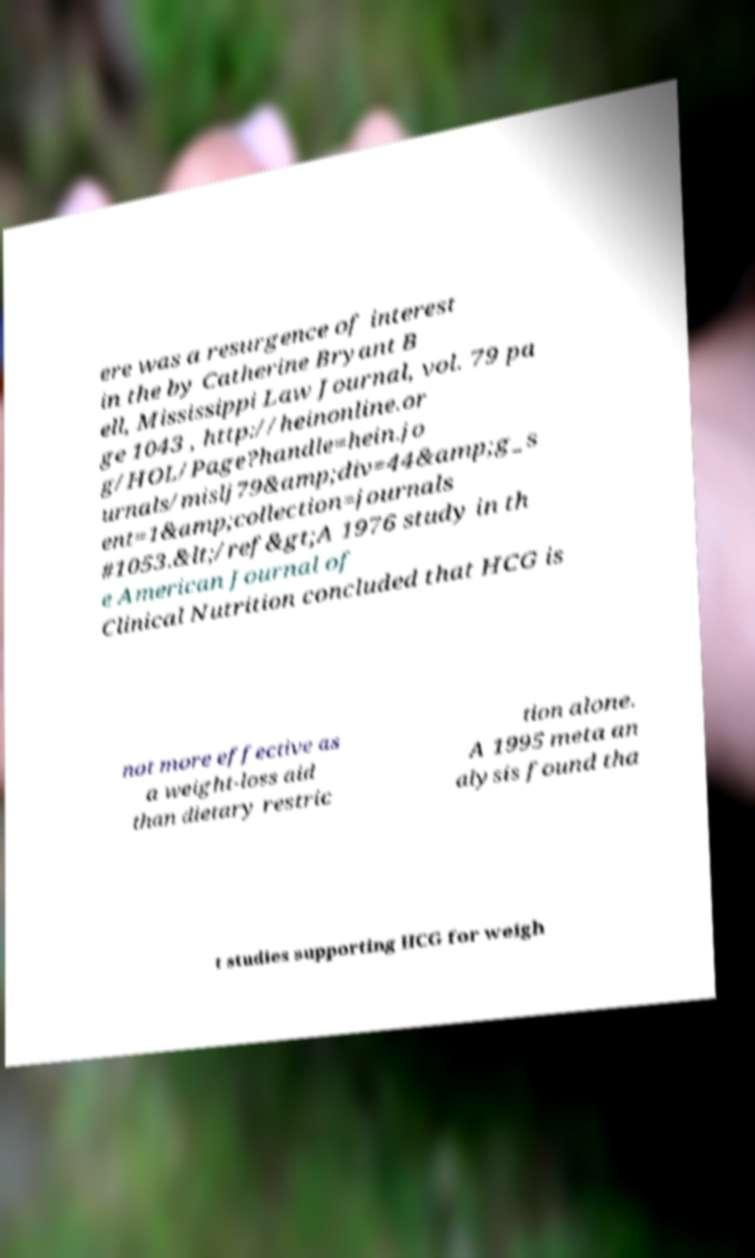Can you accurately transcribe the text from the provided image for me? ere was a resurgence of interest in the by Catherine Bryant B ell, Mississippi Law Journal, vol. 79 pa ge 1043 , http://heinonline.or g/HOL/Page?handle=hein.jo urnals/mislj79&amp;div=44&amp;g_s ent=1&amp;collection=journals #1053.&lt;/ref&gt;A 1976 study in th e American Journal of Clinical Nutrition concluded that HCG is not more effective as a weight-loss aid than dietary restric tion alone. A 1995 meta an alysis found tha t studies supporting HCG for weigh 